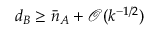Convert formula to latex. <formula><loc_0><loc_0><loc_500><loc_500>d _ { B } \geq \bar { n } _ { A } + \mathcal { O } ( k ^ { - 1 / 2 } )</formula> 